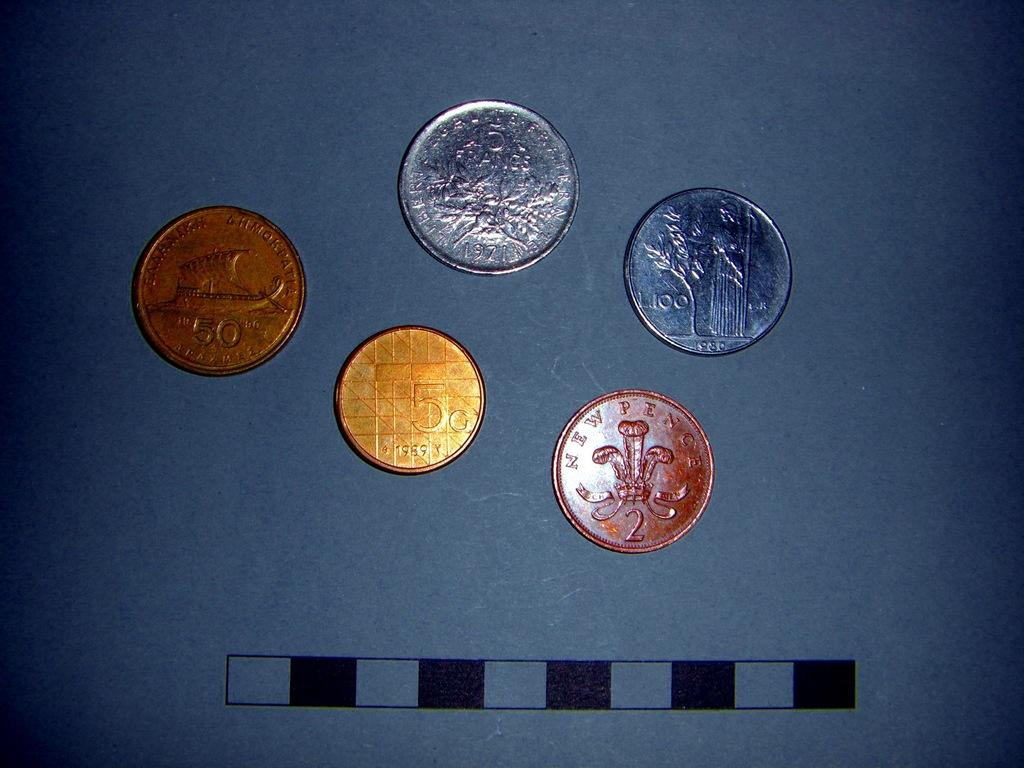<image>
Give a short and clear explanation of the subsequent image. Five coins are displayed including a gold 5c coin dated 1989. 